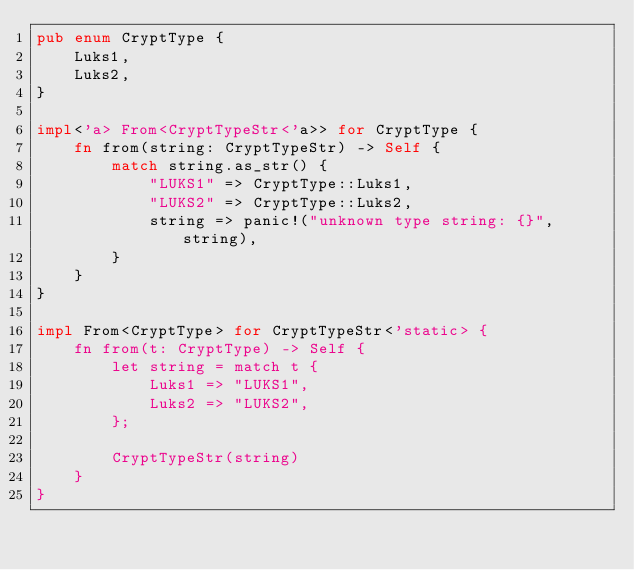Convert code to text. <code><loc_0><loc_0><loc_500><loc_500><_Rust_>pub enum CryptType {
    Luks1,
    Luks2,
}

impl<'a> From<CryptTypeStr<'a>> for CryptType {
    fn from(string: CryptTypeStr) -> Self {
        match string.as_str() {
            "LUKS1" => CryptType::Luks1,
            "LUKS2" => CryptType::Luks2,
            string => panic!("unknown type string: {}", string),
        }
    }
}

impl From<CryptType> for CryptTypeStr<'static> {
    fn from(t: CryptType) -> Self {
        let string = match t {
            Luks1 => "LUKS1",
            Luks2 => "LUKS2",
        };

        CryptTypeStr(string)
    }
}
</code> 